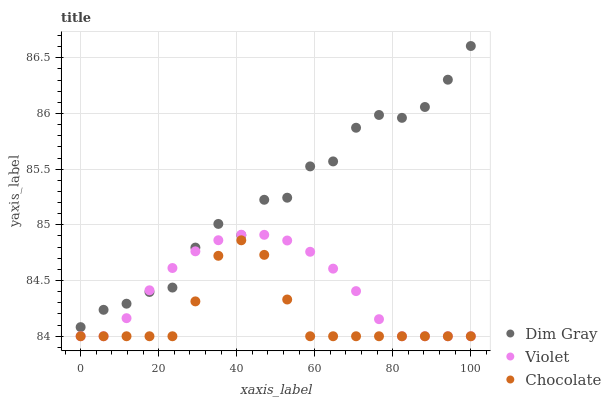Does Chocolate have the minimum area under the curve?
Answer yes or no. Yes. Does Dim Gray have the maximum area under the curve?
Answer yes or no. Yes. Does Violet have the minimum area under the curve?
Answer yes or no. No. Does Violet have the maximum area under the curve?
Answer yes or no. No. Is Violet the smoothest?
Answer yes or no. Yes. Is Dim Gray the roughest?
Answer yes or no. Yes. Is Dim Gray the smoothest?
Answer yes or no. No. Is Violet the roughest?
Answer yes or no. No. Does Chocolate have the lowest value?
Answer yes or no. Yes. Does Dim Gray have the lowest value?
Answer yes or no. No. Does Dim Gray have the highest value?
Answer yes or no. Yes. Does Violet have the highest value?
Answer yes or no. No. Is Chocolate less than Dim Gray?
Answer yes or no. Yes. Is Dim Gray greater than Chocolate?
Answer yes or no. Yes. Does Dim Gray intersect Violet?
Answer yes or no. Yes. Is Dim Gray less than Violet?
Answer yes or no. No. Is Dim Gray greater than Violet?
Answer yes or no. No. Does Chocolate intersect Dim Gray?
Answer yes or no. No. 